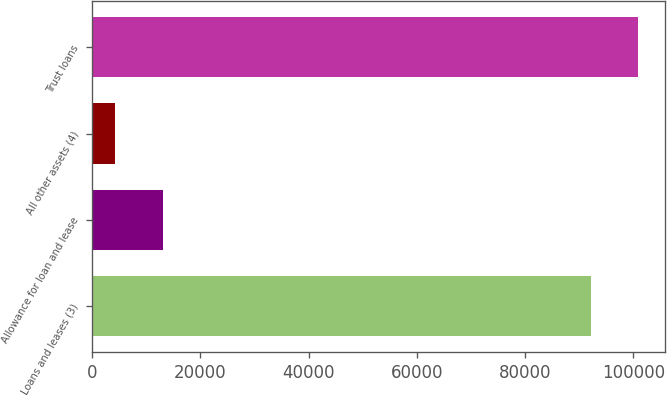<chart> <loc_0><loc_0><loc_500><loc_500><bar_chart><fcel>Loans and leases (3)<fcel>Allowance for loan and lease<fcel>All other assets (4)<fcel>Trust loans<nl><fcel>92104<fcel>13043.5<fcel>4259<fcel>100888<nl></chart> 